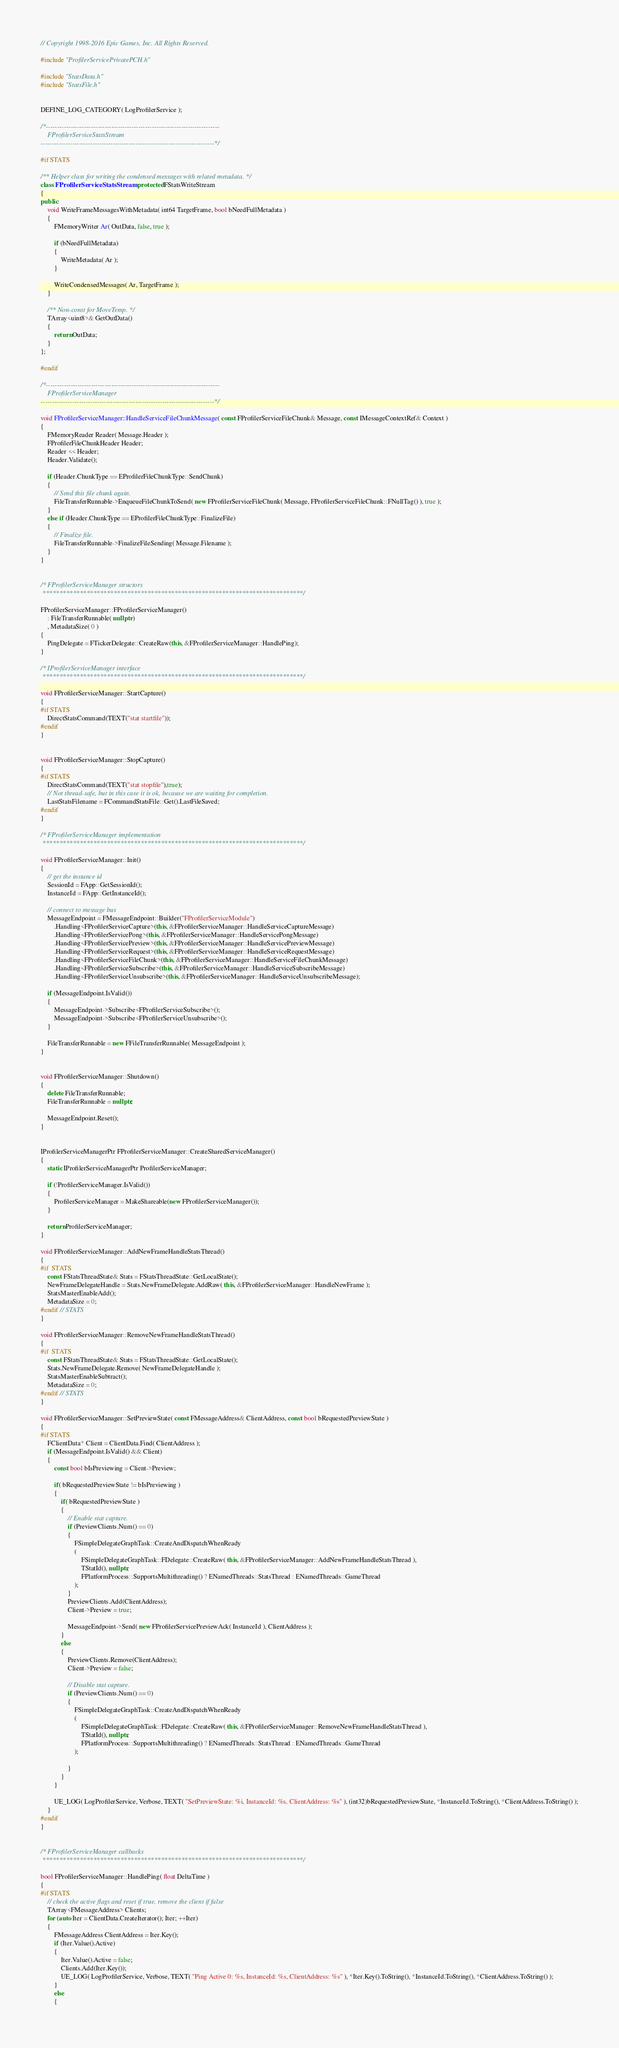<code> <loc_0><loc_0><loc_500><loc_500><_C++_>// Copyright 1998-2016 Epic Games, Inc. All Rights Reserved.

#include "ProfilerServicePrivatePCH.h"

#include "StatsData.h"
#include "StatsFile.h"


DEFINE_LOG_CATEGORY( LogProfilerService );

/*-----------------------------------------------------------------------------
	FProfilerServiceStatsStream
-----------------------------------------------------------------------------*/

#if STATS

/** Helper class for writing the condensed messages with related metadata. */
class FProfilerServiceStatsStream : protected FStatsWriteStream
{
public:
	void WriteFrameMessagesWithMetadata( int64 TargetFrame, bool bNeedFullMetadata )
	{
		FMemoryWriter Ar( OutData, false, true );

		if (bNeedFullMetadata)
		{
			WriteMetadata( Ar );
		}

		WriteCondensedMessages( Ar, TargetFrame );
	}

	/** Non-const for MoveTemp. */
	TArray<uint8>& GetOutData()
	{
		return OutData;
	}
};

#endif

/*-----------------------------------------------------------------------------
	FProfilerServiceManager
-----------------------------------------------------------------------------*/

void FProfilerServiceManager::HandleServiceFileChunkMessage( const FProfilerServiceFileChunk& Message, const IMessageContextRef& Context )
{
	FMemoryReader Reader( Message.Header );
	FProfilerFileChunkHeader Header;
	Reader << Header;
	Header.Validate();

	if (Header.ChunkType == EProfilerFileChunkType::SendChunk)
	{
		// Send this file chunk again.
		FileTransferRunnable->EnqueueFileChunkToSend( new FProfilerServiceFileChunk( Message, FProfilerServiceFileChunk::FNullTag() ), true );
	}
	else if (Header.ChunkType == EProfilerFileChunkType::FinalizeFile)
	{
		// Finalize file.
		FileTransferRunnable->FinalizeFileSending( Message.Filename );
	}
}


/* FProfilerServiceManager structors
 *****************************************************************************/

FProfilerServiceManager::FProfilerServiceManager()
	: FileTransferRunnable( nullptr )
	, MetadataSize( 0 )
{
	PingDelegate = FTickerDelegate::CreateRaw(this, &FProfilerServiceManager::HandlePing);
}

/* IProfilerServiceManager interface
 *****************************************************************************/

void FProfilerServiceManager::StartCapture()
{
#if STATS
	DirectStatsCommand(TEXT("stat startfile"));
#endif
}


void FProfilerServiceManager::StopCapture()
{
#if STATS
	DirectStatsCommand(TEXT("stat stopfile"),true);
	// Not thread-safe, but in this case it is ok, because we are waiting for completion.
	LastStatsFilename = FCommandStatsFile::Get().LastFileSaved;
#endif
}

/* FProfilerServiceManager implementation
 *****************************************************************************/

void FProfilerServiceManager::Init()
{
	// get the instance id
	SessionId = FApp::GetSessionId();
	InstanceId = FApp::GetInstanceId();

	// connect to message bus
	MessageEndpoint = FMessageEndpoint::Builder("FProfilerServiceModule")
		.Handling<FProfilerServiceCapture>(this, &FProfilerServiceManager::HandleServiceCaptureMessage)	
		.Handling<FProfilerServicePong>(this, &FProfilerServiceManager::HandleServicePongMessage)
		.Handling<FProfilerServicePreview>(this, &FProfilerServiceManager::HandleServicePreviewMessage)
		.Handling<FProfilerServiceRequest>(this, &FProfilerServiceManager::HandleServiceRequestMessage)
		.Handling<FProfilerServiceFileChunk>(this, &FProfilerServiceManager::HandleServiceFileChunkMessage)
		.Handling<FProfilerServiceSubscribe>(this, &FProfilerServiceManager::HandleServiceSubscribeMessage)
		.Handling<FProfilerServiceUnsubscribe>(this, &FProfilerServiceManager::HandleServiceUnsubscribeMessage);

	if (MessageEndpoint.IsValid())
	{
		MessageEndpoint->Subscribe<FProfilerServiceSubscribe>();
		MessageEndpoint->Subscribe<FProfilerServiceUnsubscribe>();
	}

	FileTransferRunnable = new FFileTransferRunnable( MessageEndpoint );
}


void FProfilerServiceManager::Shutdown()
{
	delete FileTransferRunnable;
	FileTransferRunnable = nullptr;

	MessageEndpoint.Reset();
}


IProfilerServiceManagerPtr FProfilerServiceManager::CreateSharedServiceManager()
{
	static IProfilerServiceManagerPtr ProfilerServiceManager;

	if (!ProfilerServiceManager.IsValid())
	{
		ProfilerServiceManager = MakeShareable(new FProfilerServiceManager());
	}

	return ProfilerServiceManager;
}

void FProfilerServiceManager::AddNewFrameHandleStatsThread()
{
#if	STATS
	const FStatsThreadState& Stats = FStatsThreadState::GetLocalState();
	NewFrameDelegateHandle = Stats.NewFrameDelegate.AddRaw( this, &FProfilerServiceManager::HandleNewFrame );
	StatsMasterEnableAdd();
	MetadataSize = 0;
#endif // STATS
}

void FProfilerServiceManager::RemoveNewFrameHandleStatsThread()
{
#if	STATS
	const FStatsThreadState& Stats = FStatsThreadState::GetLocalState();
	Stats.NewFrameDelegate.Remove( NewFrameDelegateHandle );
	StatsMasterEnableSubtract();
	MetadataSize = 0;
#endif // STATS
}

void FProfilerServiceManager::SetPreviewState( const FMessageAddress& ClientAddress, const bool bRequestedPreviewState )
{
#if STATS
	FClientData* Client = ClientData.Find( ClientAddress );
	if (MessageEndpoint.IsValid() && Client)
	{
		const bool bIsPreviewing = Client->Preview;

		if( bRequestedPreviewState != bIsPreviewing )
		{
			if( bRequestedPreviewState )
			{
				// Enable stat capture.
				if (PreviewClients.Num() == 0)
				{
					FSimpleDelegateGraphTask::CreateAndDispatchWhenReady
					(
						FSimpleDelegateGraphTask::FDelegate::CreateRaw( this, &FProfilerServiceManager::AddNewFrameHandleStatsThread ),
						TStatId(), nullptr,
						FPlatformProcess::SupportsMultithreading() ? ENamedThreads::StatsThread : ENamedThreads::GameThread
					);
				}
				PreviewClients.Add(ClientAddress);
				Client->Preview = true;

				MessageEndpoint->Send( new FProfilerServicePreviewAck( InstanceId ), ClientAddress );
			}
			else
			{
				PreviewClients.Remove(ClientAddress);
				Client->Preview = false;

				// Disable stat capture.
				if (PreviewClients.Num() == 0)
				{
					FSimpleDelegateGraphTask::CreateAndDispatchWhenReady
					(
						FSimpleDelegateGraphTask::FDelegate::CreateRaw( this, &FProfilerServiceManager::RemoveNewFrameHandleStatsThread ),
						TStatId(), nullptr,
						FPlatformProcess::SupportsMultithreading() ? ENamedThreads::StatsThread : ENamedThreads::GameThread
					);
					
				}	
			}
		}

		UE_LOG( LogProfilerService, Verbose, TEXT( "SetPreviewState: %i, InstanceId: %s, ClientAddress: %s" ), (int32)bRequestedPreviewState, *InstanceId.ToString(), *ClientAddress.ToString() );
	}
#endif
}


/* FProfilerServiceManager callbacks
 *****************************************************************************/

bool FProfilerServiceManager::HandlePing( float DeltaTime )
{
#if STATS
	// check the active flags and reset if true, remove the client if false
	TArray<FMessageAddress> Clients;
	for (auto Iter = ClientData.CreateIterator(); Iter; ++Iter)
	{
		FMessageAddress ClientAddress = Iter.Key();
		if (Iter.Value().Active)
		{
			Iter.Value().Active = false;
			Clients.Add(Iter.Key());
			UE_LOG( LogProfilerService, Verbose, TEXT( "Ping Active 0: %s, InstanceId: %s, ClientAddress: %s" ), *Iter.Key().ToString(), *InstanceId.ToString(), *ClientAddress.ToString() );
		}
		else
		{</code> 